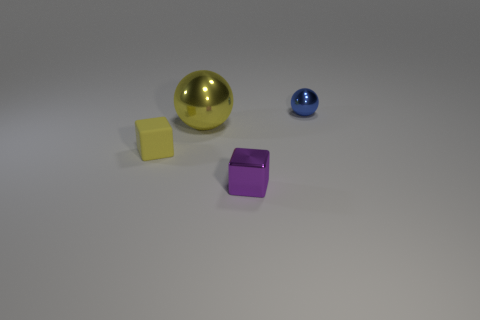How many tiny yellow matte objects are to the left of the cube that is on the right side of the sphere that is to the left of the blue thing?
Give a very brief answer. 1. The other object that is the same shape as the large thing is what size?
Your answer should be compact. Small. Are there any other things that are the same size as the yellow ball?
Keep it short and to the point. No. Does the sphere that is on the right side of the tiny purple shiny thing have the same material as the yellow cube?
Make the answer very short. No. There is another object that is the same shape as the tiny matte object; what is its color?
Offer a terse response. Purple. How many other things are the same color as the small metal cube?
Your answer should be compact. 0. There is a metal object in front of the small yellow matte object; is it the same shape as the small object that is behind the tiny yellow thing?
Your answer should be very brief. No. What number of blocks are either small purple objects or small matte things?
Provide a succinct answer. 2. Is the number of blue balls in front of the big yellow metal object less than the number of tiny cyan metallic objects?
Ensure brevity in your answer.  No. What number of other things are there of the same material as the small blue sphere
Your answer should be compact. 2. 